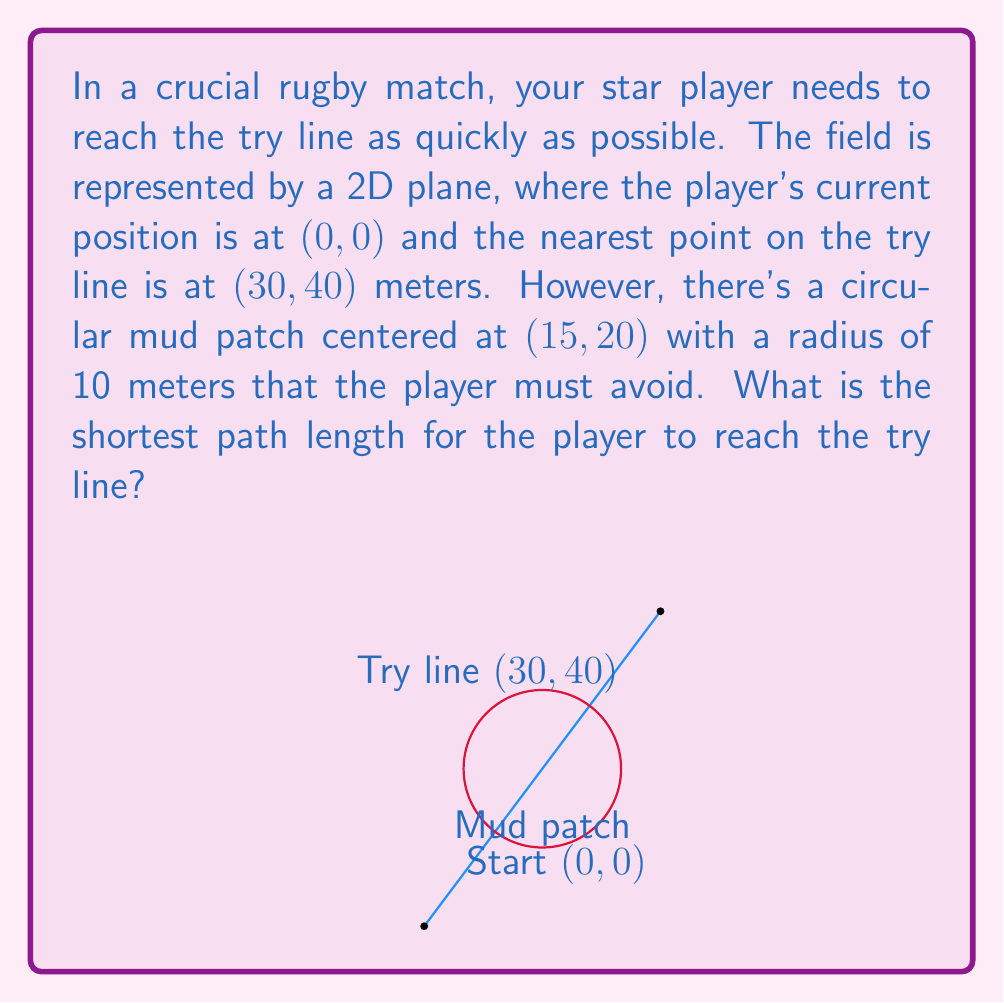Can you answer this question? Let's approach this step-by-step:

1) First, we need to determine if the direct path intersects with the mud patch. The straight-line distance between the start and end points is:

   $$d = \sqrt{30^2 + 40^2} = 50\text{ meters}$$

2) To check if this path intersects the mud patch, we can use the distance from a point to a line formula. The distance from the center of the mud patch (15, 20) to the line connecting (0, 0) and (30, 40) is:

   $$d = \frac{|40 \cdot 15 - 30 \cdot 20 + 30 \cdot 0 - 0 \cdot 40|}{\sqrt{30^2 + 40^2}} = 6\text{ meters}$$

3) Since this distance (6m) is less than the radius of the mud patch (10m), the direct path intersects the mud patch and is not valid.

4) The shortest path will now consist of two line segments: from the start point to a point on the edge of the mud patch, and from that point to the try line. This path will be tangent to the mud patch circle.

5) To find this path, we can use the method of bitangents to circles. The equations are complex, but the result gives us two tangent points: one on each side of the mud patch.

6) Calculating these points (which involves solving a system of equations) gives us approximately (8.39, 11.19) and (21.61, 28.81).

7) The total path length will be the sum of the distances from start to tangent point and from tangent point to the try line. Calculating for both possible tangent points, we find the shorter path uses the point (21.61, 28.81).

8) The final path length is:

   $$\sqrt{21.61^2 + 28.81^2} + \sqrt{(30-21.61)^2 + (40-28.81)^2} \approx 50.63\text{ meters}$$
Answer: $50.63\text{ meters}$ 